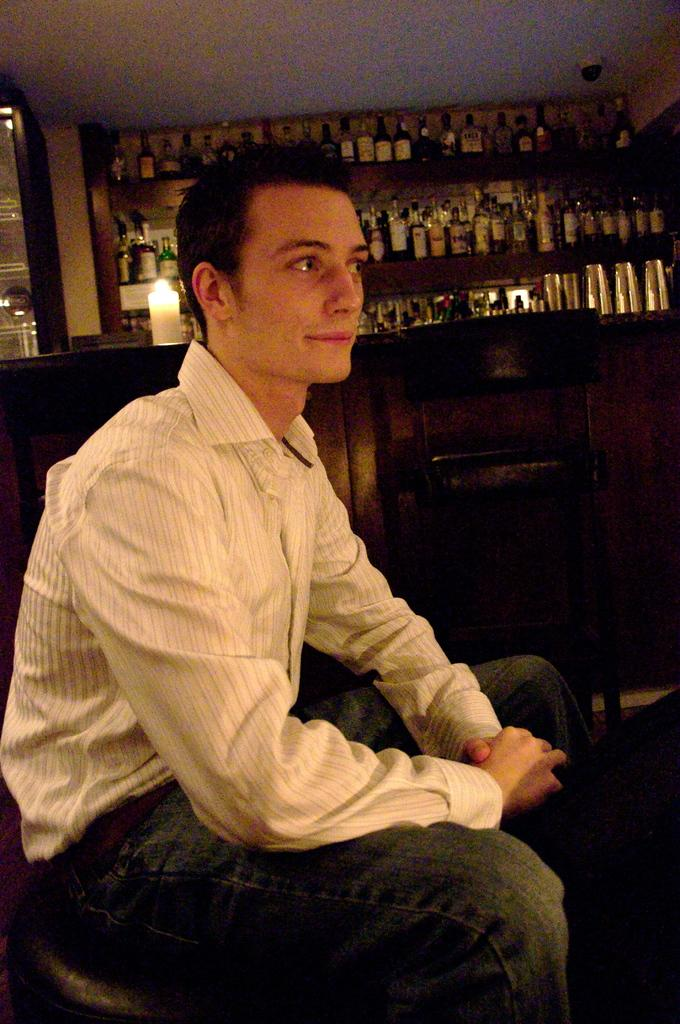What is the position of the man in the image? There is a man sitting in the front of the image. What can be seen in the center of the image? There is an empty chair in the center of the image. What objects are visible in the background of the image? There are bottles and a candle in the background of the image. What type of string is being used to make the hen's discovery in the image? There is no hen or string present in the image, and therefore no such discovery can be observed. 